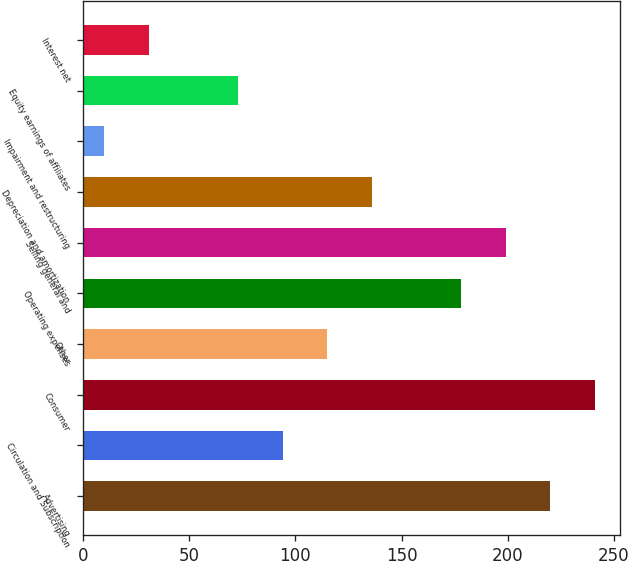Convert chart to OTSL. <chart><loc_0><loc_0><loc_500><loc_500><bar_chart><fcel>Advertising<fcel>Circulation and Subscription<fcel>Consumer<fcel>Other<fcel>Operating expenses<fcel>Selling general and<fcel>Depreciation and amortization<fcel>Impairment and restructuring<fcel>Equity earnings of affiliates<fcel>Interest net<nl><fcel>220<fcel>94<fcel>241<fcel>115<fcel>178<fcel>199<fcel>136<fcel>10<fcel>73<fcel>31<nl></chart> 